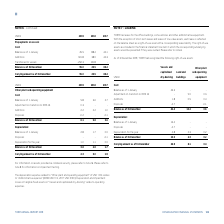According to Torm's financial document, What information can be derived in note 16? information on assets provided as collateral security. The document states: "For information on assets provided as collateral security, please refer to note 16. Please refer to note 8 for information on impairment testing. The ..." Also, What was the depreciation expense related to Other plant and operating equipment? According to the financial document, USD 1.0m. The relevant text states: "lated to "Other plant and operating equipment" of USD 1.0m relates to "Administrative expense" (2018: USD 1.1m, 2017: USD 0.9m). Depreciation and impairment l..." Also, What are the broad categories analyzed under Other plant and operating equipment? The document shows two values: Cost and Depreciation. From the document: "Cost: Depreciation:..." Additionally, In which year was the amount of depreciation for the year the largest? According to the financial document, 2018. The relevant text states: "USDm 2019 2018 2017..." Also, can you calculate: What was the change in the carrying amount as of 31 December from 2018 to 2019? Based on the calculation: 4.3-3.0, the result is 1.3 (in millions). This is based on the information: "Carrying amount as of 31 December 4.3 3.0 1.9 Carrying amount as of 31 December 4.3 3.0 1.9..." The key data points involved are: 3.0, 4.3. Also, can you calculate: What was the percentage change in the carrying amount as of 31 December from 2018 to 2019? To answer this question, I need to perform calculations using the financial data. The calculation is: (4.3-3.0)/3.0, which equals 43.33 (percentage). This is based on the information: "Carrying amount as of 31 December 4.3 3.0 1.9 Carrying amount as of 31 December 4.3 3.0 1.9..." The key data points involved are: 3.0, 4.3. 